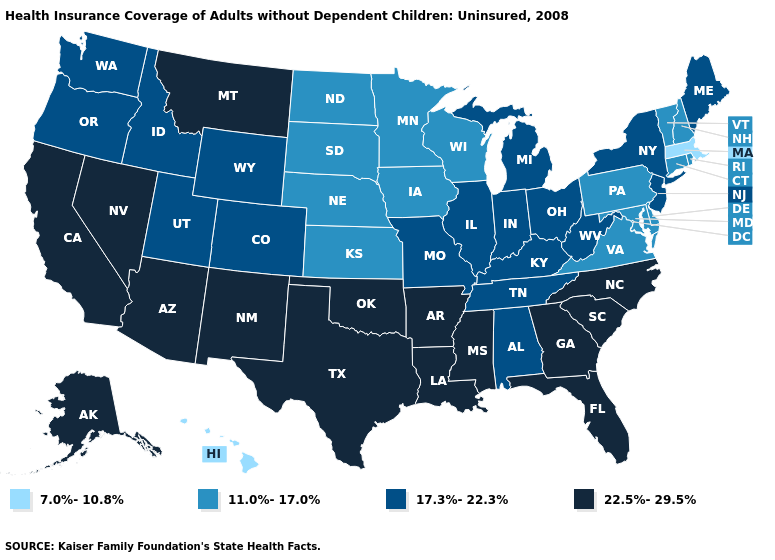Which states have the lowest value in the USA?
Keep it brief. Hawaii, Massachusetts. What is the value of Georgia?
Short answer required. 22.5%-29.5%. Name the states that have a value in the range 22.5%-29.5%?
Answer briefly. Alaska, Arizona, Arkansas, California, Florida, Georgia, Louisiana, Mississippi, Montana, Nevada, New Mexico, North Carolina, Oklahoma, South Carolina, Texas. Which states have the lowest value in the Northeast?
Write a very short answer. Massachusetts. What is the value of Florida?
Concise answer only. 22.5%-29.5%. Name the states that have a value in the range 7.0%-10.8%?
Write a very short answer. Hawaii, Massachusetts. Which states hav the highest value in the South?
Answer briefly. Arkansas, Florida, Georgia, Louisiana, Mississippi, North Carolina, Oklahoma, South Carolina, Texas. Among the states that border Colorado , which have the lowest value?
Quick response, please. Kansas, Nebraska. What is the lowest value in the USA?
Concise answer only. 7.0%-10.8%. What is the lowest value in states that border Delaware?
Keep it brief. 11.0%-17.0%. Which states have the highest value in the USA?
Give a very brief answer. Alaska, Arizona, Arkansas, California, Florida, Georgia, Louisiana, Mississippi, Montana, Nevada, New Mexico, North Carolina, Oklahoma, South Carolina, Texas. Which states have the highest value in the USA?
Answer briefly. Alaska, Arizona, Arkansas, California, Florida, Georgia, Louisiana, Mississippi, Montana, Nevada, New Mexico, North Carolina, Oklahoma, South Carolina, Texas. What is the value of Mississippi?
Quick response, please. 22.5%-29.5%. Name the states that have a value in the range 11.0%-17.0%?
Answer briefly. Connecticut, Delaware, Iowa, Kansas, Maryland, Minnesota, Nebraska, New Hampshire, North Dakota, Pennsylvania, Rhode Island, South Dakota, Vermont, Virginia, Wisconsin. Does the map have missing data?
Short answer required. No. 